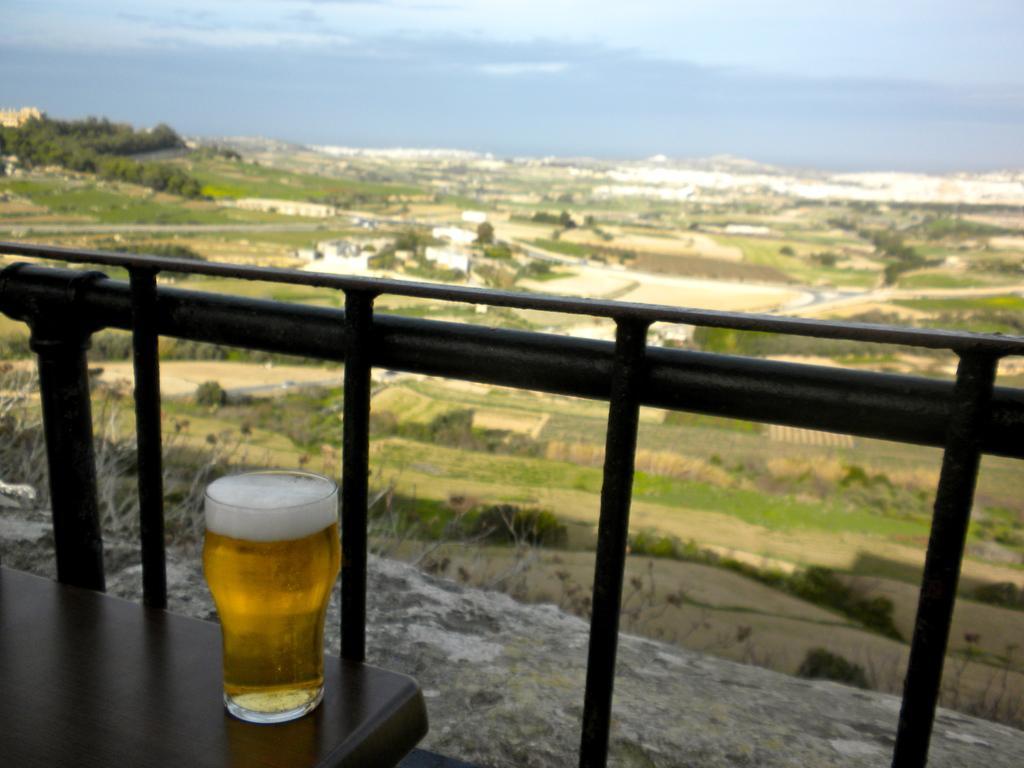In one or two sentences, can you explain what this image depicts? At the bottom left side of the image there is a table. On the table, we can see one glass. In the glass, we can see some liquid, which is in yellow color. In front of the table, there is a fence. In the background, we can see the sky, clouds, trees, plants, grass and a few other objects. 